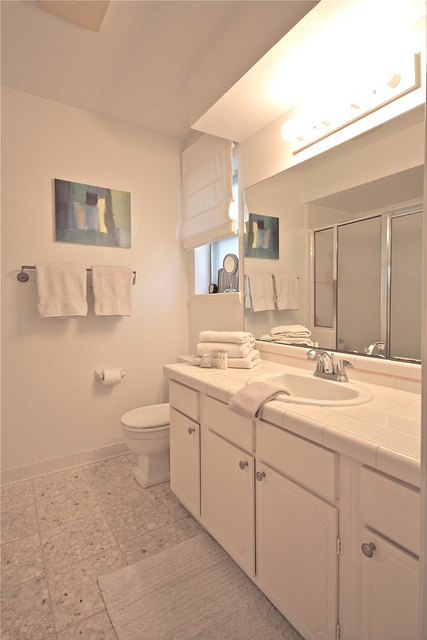Can you suggest ways to add more personal touches or color to this bathroom while maintaining its minimalist style? Personal touches can be added without compromising the minimalist style by strategically using accessories and textiles. For instance, replacing the existing towels and bath mat with items in a bold accent color such as teal or burgundy would inject color while maintaining simplicity. Adding a small potted plant on the countertop or a sleek vase with fresh flowers could provide some natural elements. A few select pieces of framed photography or artwork that reflect personal interests can be hung on the walls, giving the space more character. Lastly, using a decorative soap dispenser or toothbrush holder that complements the overall color scheme could add both function and charm. 